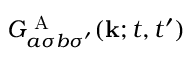<formula> <loc_0><loc_0><loc_500><loc_500>G _ { a \sigma b \sigma ^ { \prime } } ^ { A } ( k ; t , t ^ { \prime } )</formula> 